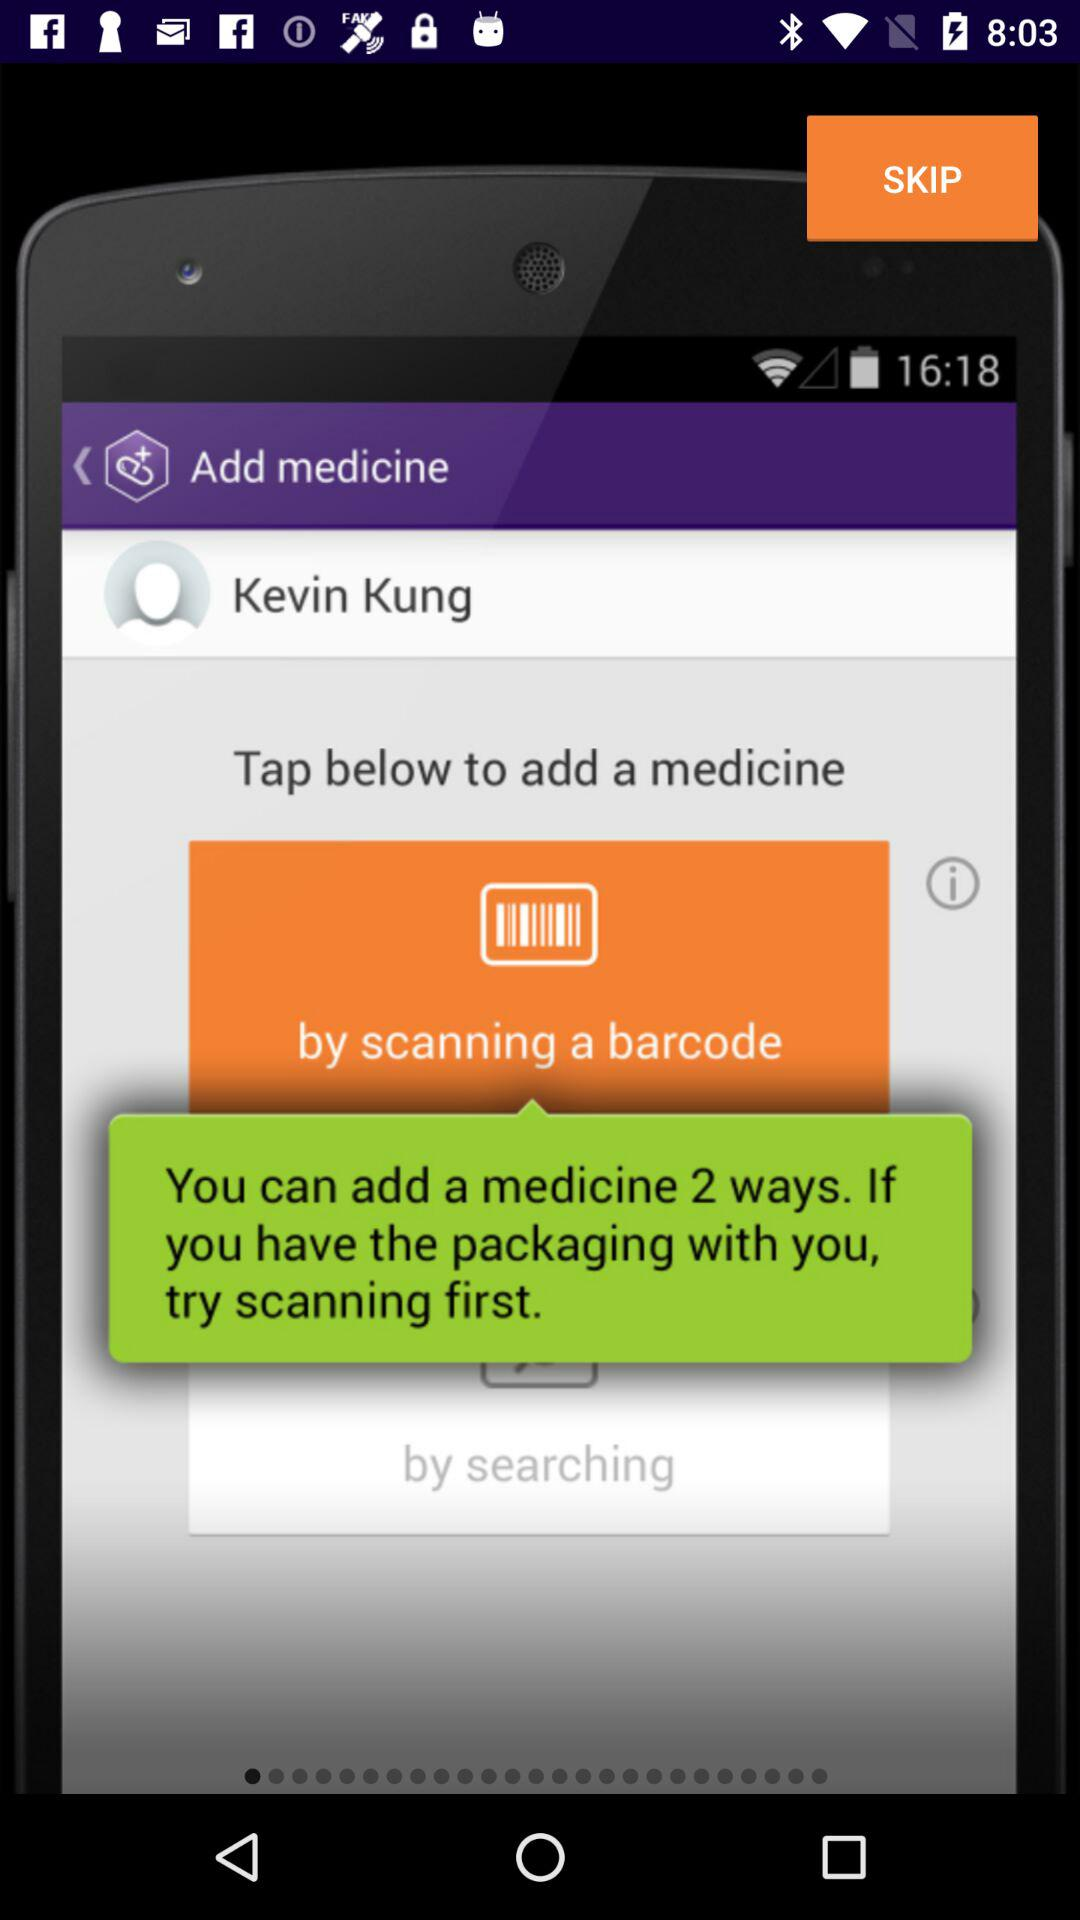What is the user name? The user name is Kevin Kung. 